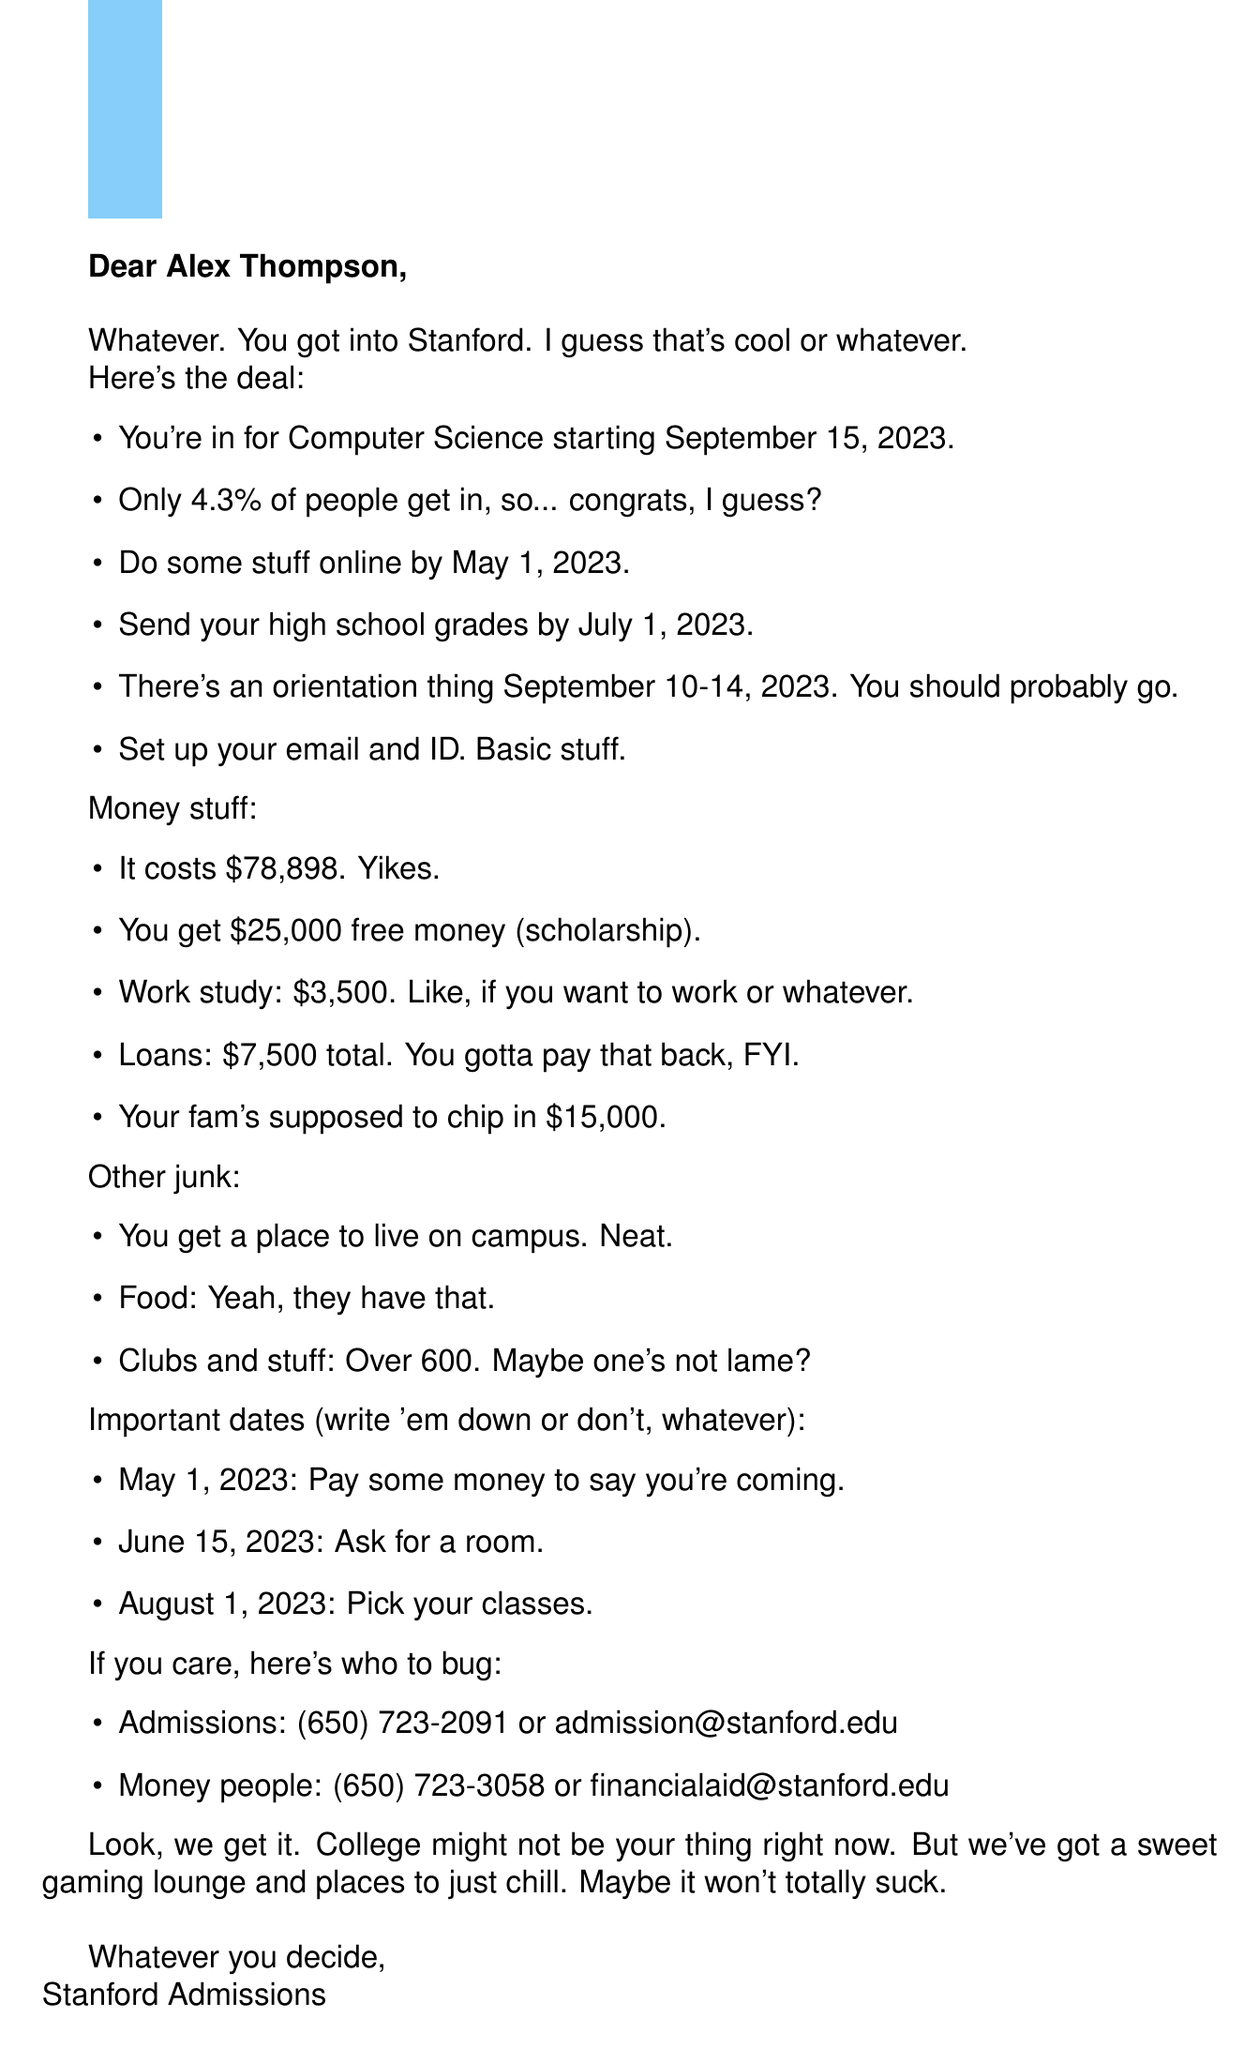What program was Alex accepted into? The document states that Alex was accepted into the Computer Science program at Stanford University.
Answer: Computer Science What is the total cost of attendance? The document mentions that the total cost of attendance is listed as $78,898.
Answer: $78,898 When is the enrollment deposit due? The letter specifies that the enrollment deposit is due by May 1, 2023.
Answer: May 1, 2023 How much scholarship money is offered? The document indicates that Alex is offered a scholarship amount of $25,000.
Answer: $25,000 What should Alex do by July 1, 2023? The document instructs that Alex must submit their final high school transcript by July 1, 2023.
Answer: Submit final high school transcript What is the orientation date range? The letter states that the New Student Orientation takes place from September 10-14, 2023.
Answer: September 10-14, 2023 What is the expected family contribution? The document notes that the expected family contribution is $15,000.
Answer: $15,000 How many student organizations are available? The document mentions that there are over 600 student organizations for Alex to choose from.
Answer: Over 600 What is the phone number for the admissions office? The letter provides the phone number for the admissions office as (650) 723-2091.
Answer: (650) 723-2091 